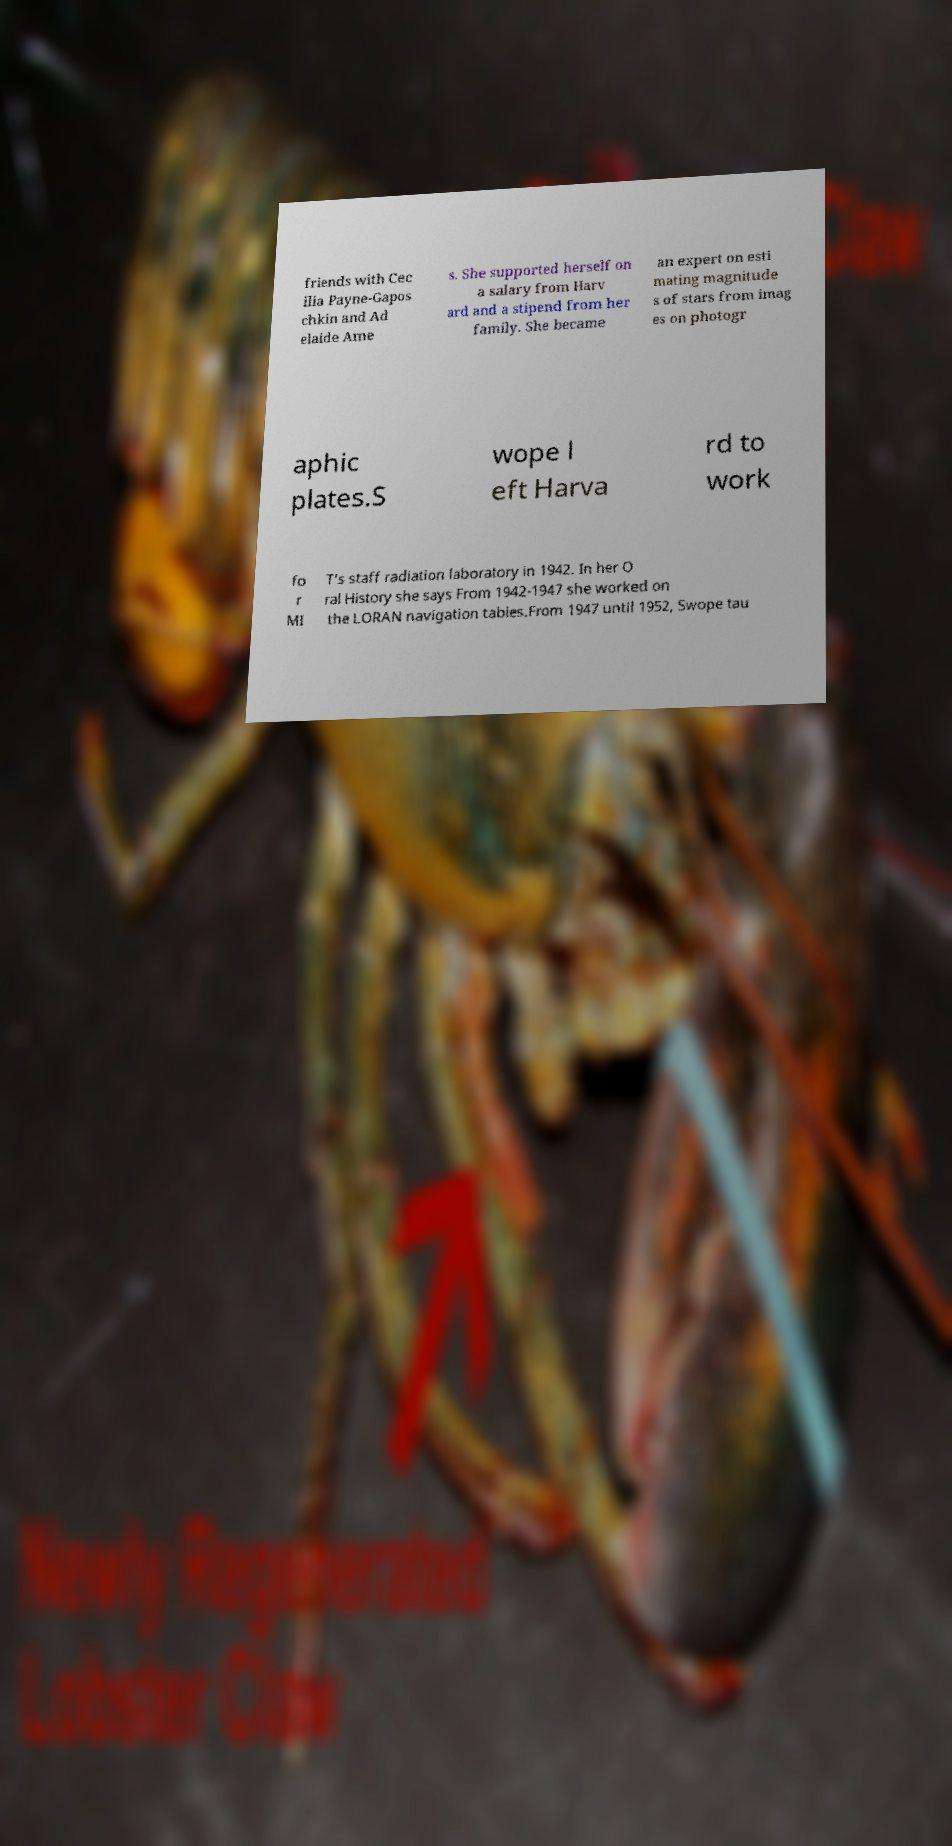Could you assist in decoding the text presented in this image and type it out clearly? friends with Cec ilia Payne-Gapos chkin and Ad elaide Ame s. She supported herself on a salary from Harv ard and a stipend from her family. She became an expert on esti mating magnitude s of stars from imag es on photogr aphic plates.S wope l eft Harva rd to work fo r MI T's staff radiation laboratory in 1942. In her O ral History she says From 1942-1947 she worked on the LORAN navigation tables.From 1947 until 1952, Swope tau 